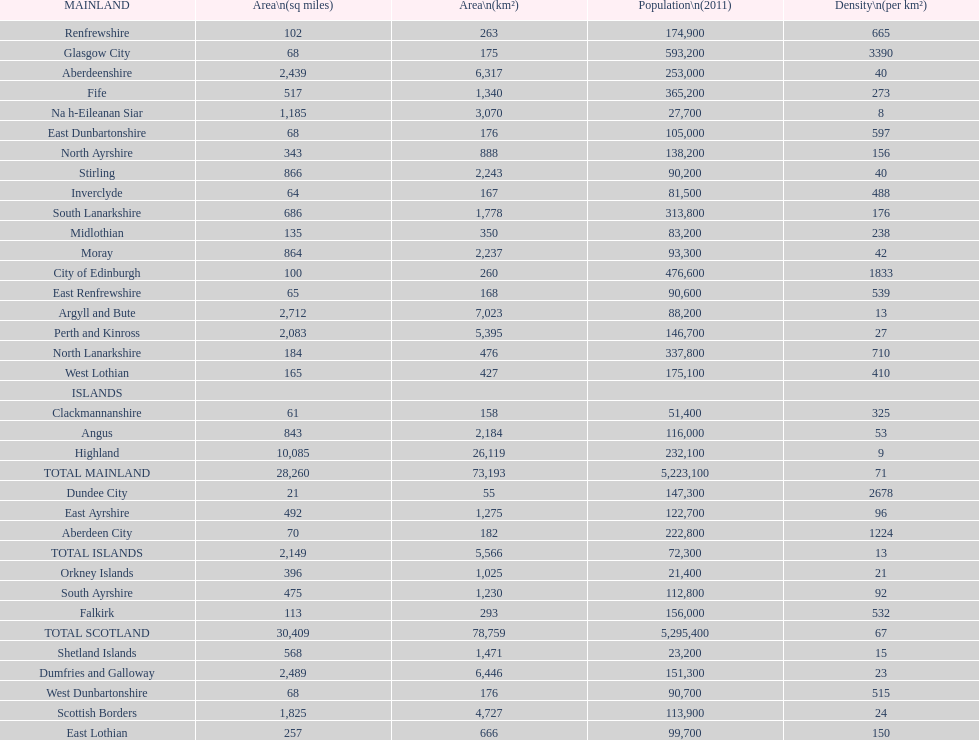Which mainland has the least population? Clackmannanshire. 